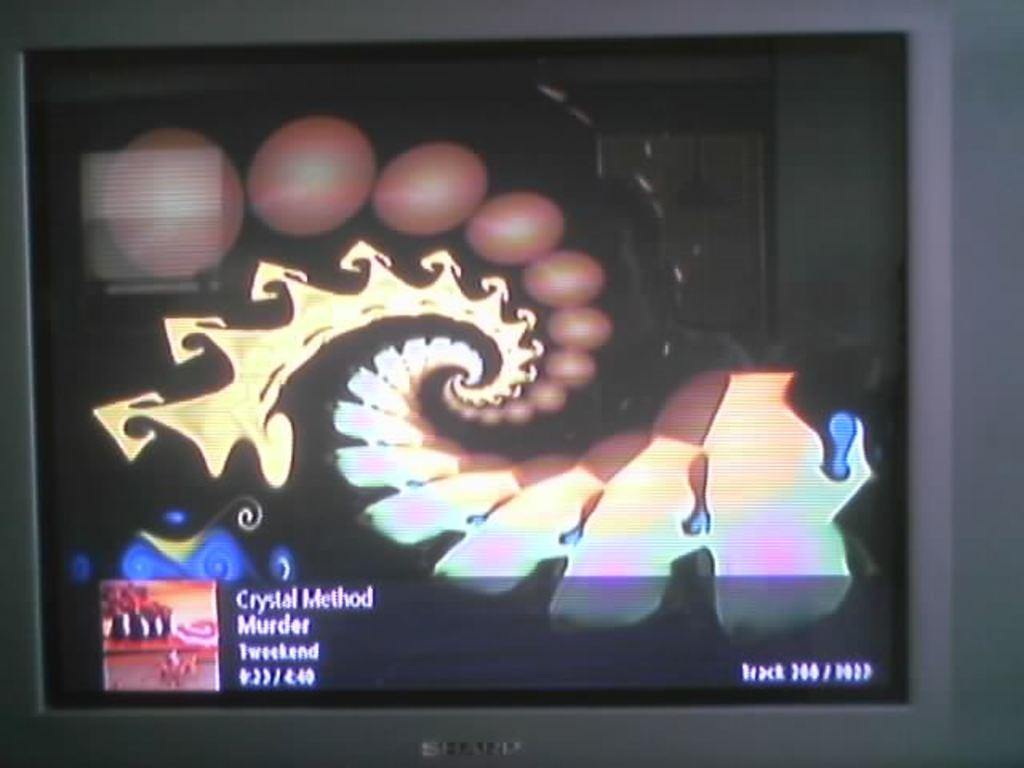<image>
Create a compact narrative representing the image presented. The TV screen is playing a video from the band Crystal Method. 